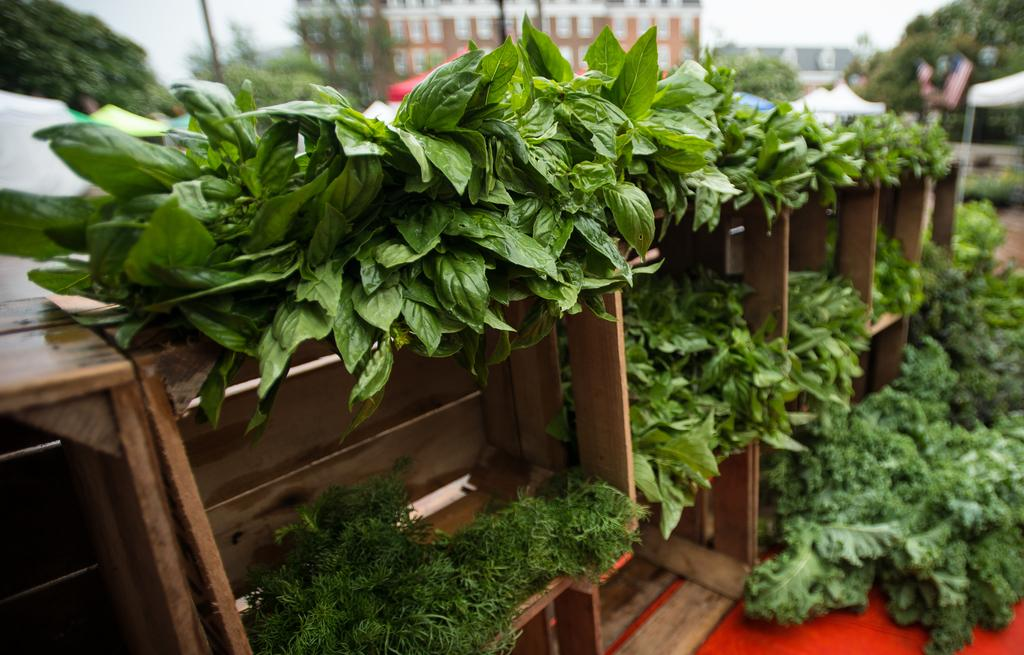What type of material is the wooden object covered with in the image? The wooden object is covered with green leaves in the image. What type of vegetable can be seen in the right corner of the image? There are broccoli in the right corner of the image. What can be seen in the background of the image? There is a building in the background of the image. Can you tell me how many records are stacked on the wooden object in the image? There are no records present in the image. Is there a deer visible in the image? There is no deer present in the image. 